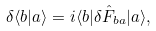Convert formula to latex. <formula><loc_0><loc_0><loc_500><loc_500>\delta \langle b | a \rangle = i \langle b | \delta \hat { F } _ { b a } | a \rangle ,</formula> 